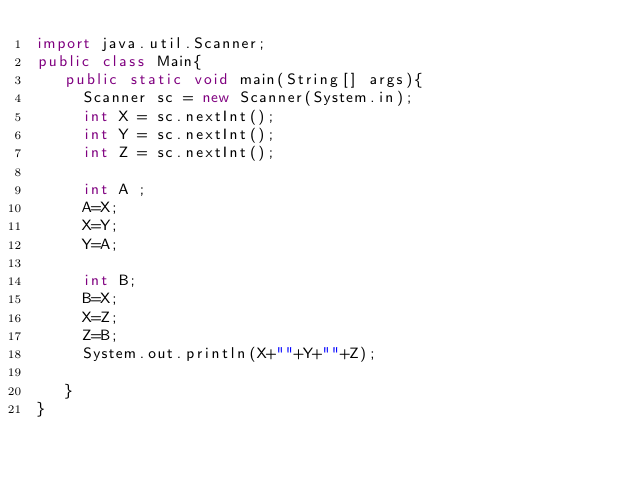Convert code to text. <code><loc_0><loc_0><loc_500><loc_500><_Java_>import java.util.Scanner;
public class Main{
   public static void main(String[] args){
     Scanner sc = new Scanner(System.in);
     int X = sc.nextInt();
     int Y = sc.nextInt();
     int Z = sc.nextInt();
     
     int A ;
     A=X;
     X=Y;
     Y=A;
     
     int B;
     B=X;
     X=Z;
     Z=B;
     System.out.println(X+""+Y+""+Z);
    
   }
}  
  
</code> 